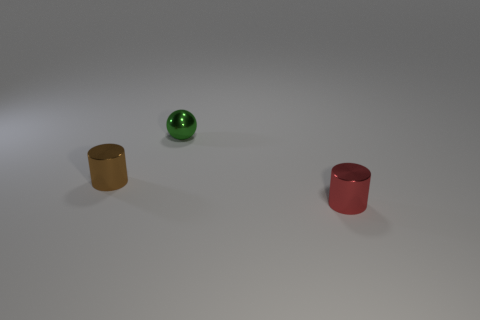How many cylinders are big brown rubber things or green shiny objects?
Your answer should be compact. 0. Is there a tiny red thing that has the same shape as the brown metal object?
Offer a terse response. Yes. What is the shape of the red thing?
Provide a succinct answer. Cylinder. What number of objects are small spheres or small cylinders?
Offer a terse response. 3. Do the cylinder that is in front of the tiny brown shiny cylinder and the metal thing that is to the left of the tiny green sphere have the same size?
Make the answer very short. Yes. How many other objects are the same material as the tiny sphere?
Ensure brevity in your answer.  2. Are there more shiny cylinders that are in front of the metal ball than shiny balls in front of the tiny red metallic thing?
Make the answer very short. Yes. What is the thing on the left side of the green sphere made of?
Provide a succinct answer. Metal. Do the red thing and the tiny brown thing have the same shape?
Your answer should be compact. Yes. Are there any other things that have the same color as the ball?
Make the answer very short. No. 